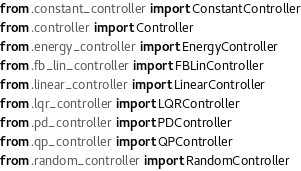Convert code to text. <code><loc_0><loc_0><loc_500><loc_500><_Python_>from .constant_controller import ConstantController
from .controller import Controller
from .energy_controller import EnergyController
from .fb_lin_controller import FBLinController
from .linear_controller import LinearController
from .lqr_controller import LQRController
from .pd_controller import PDController
from .qp_controller import QPController
from .random_controller import RandomController</code> 